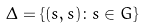<formula> <loc_0><loc_0><loc_500><loc_500>\Delta = \{ ( s , s ) \colon s \in G \}</formula> 